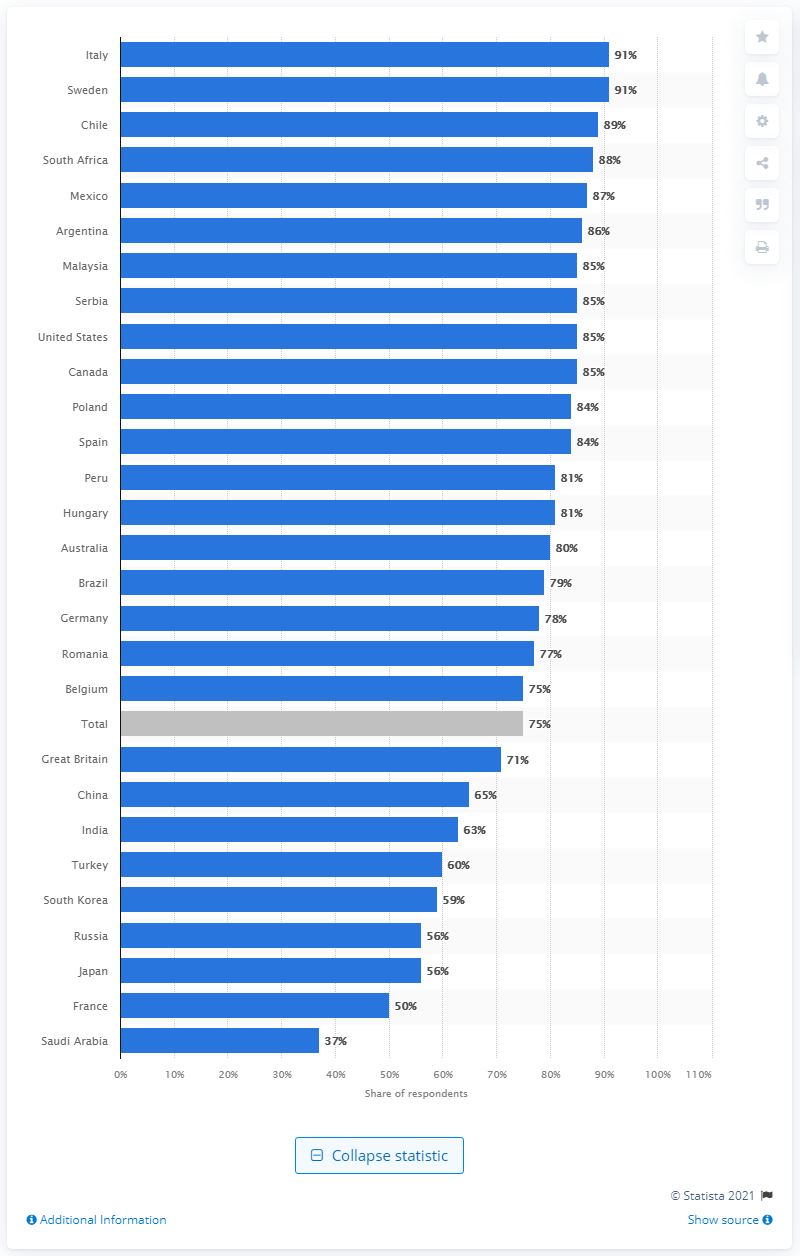Mention a couple of crucial points in this snapshot. Sweden has the highest rate of cyber bullying awareness among countries. 